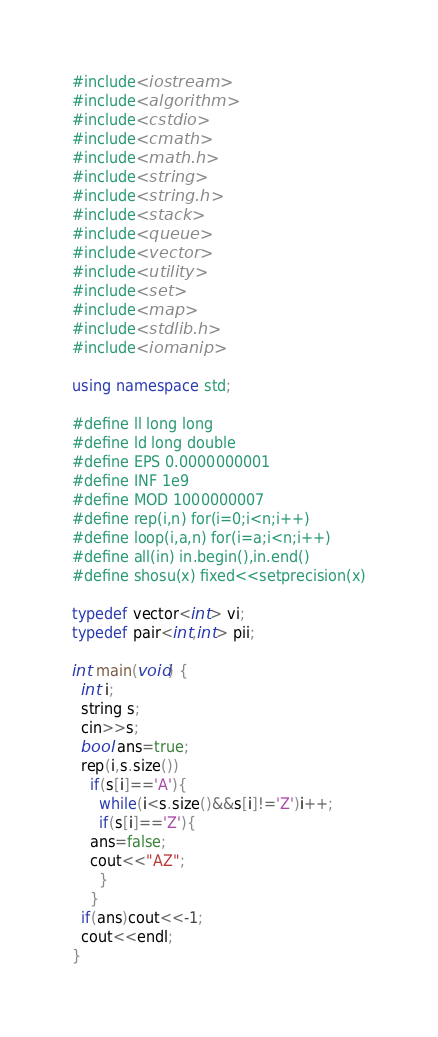Convert code to text. <code><loc_0><loc_0><loc_500><loc_500><_C++_>#include<iostream>
#include<algorithm>
#include<cstdio>
#include<cmath>
#include<math.h>
#include<string>
#include<string.h>
#include<stack>
#include<queue>
#include<vector>
#include<utility>
#include<set>
#include<map>
#include<stdlib.h>
#include<iomanip>

using namespace std;

#define ll long long
#define ld long double
#define EPS 0.0000000001
#define INF 1e9
#define MOD 1000000007
#define rep(i,n) for(i=0;i<n;i++)
#define loop(i,a,n) for(i=a;i<n;i++)
#define all(in) in.begin(),in.end()
#define shosu(x) fixed<<setprecision(x)

typedef vector<int> vi;
typedef pair<int,int> pii;

int main(void) {
  int i;
  string s;
  cin>>s;
  bool ans=true;
  rep(i,s.size())
    if(s[i]=='A'){
      while(i<s.size()&&s[i]!='Z')i++;
      if(s[i]=='Z'){
	ans=false;
	cout<<"AZ";
      }
    }
  if(ans)cout<<-1;
  cout<<endl;
}</code> 